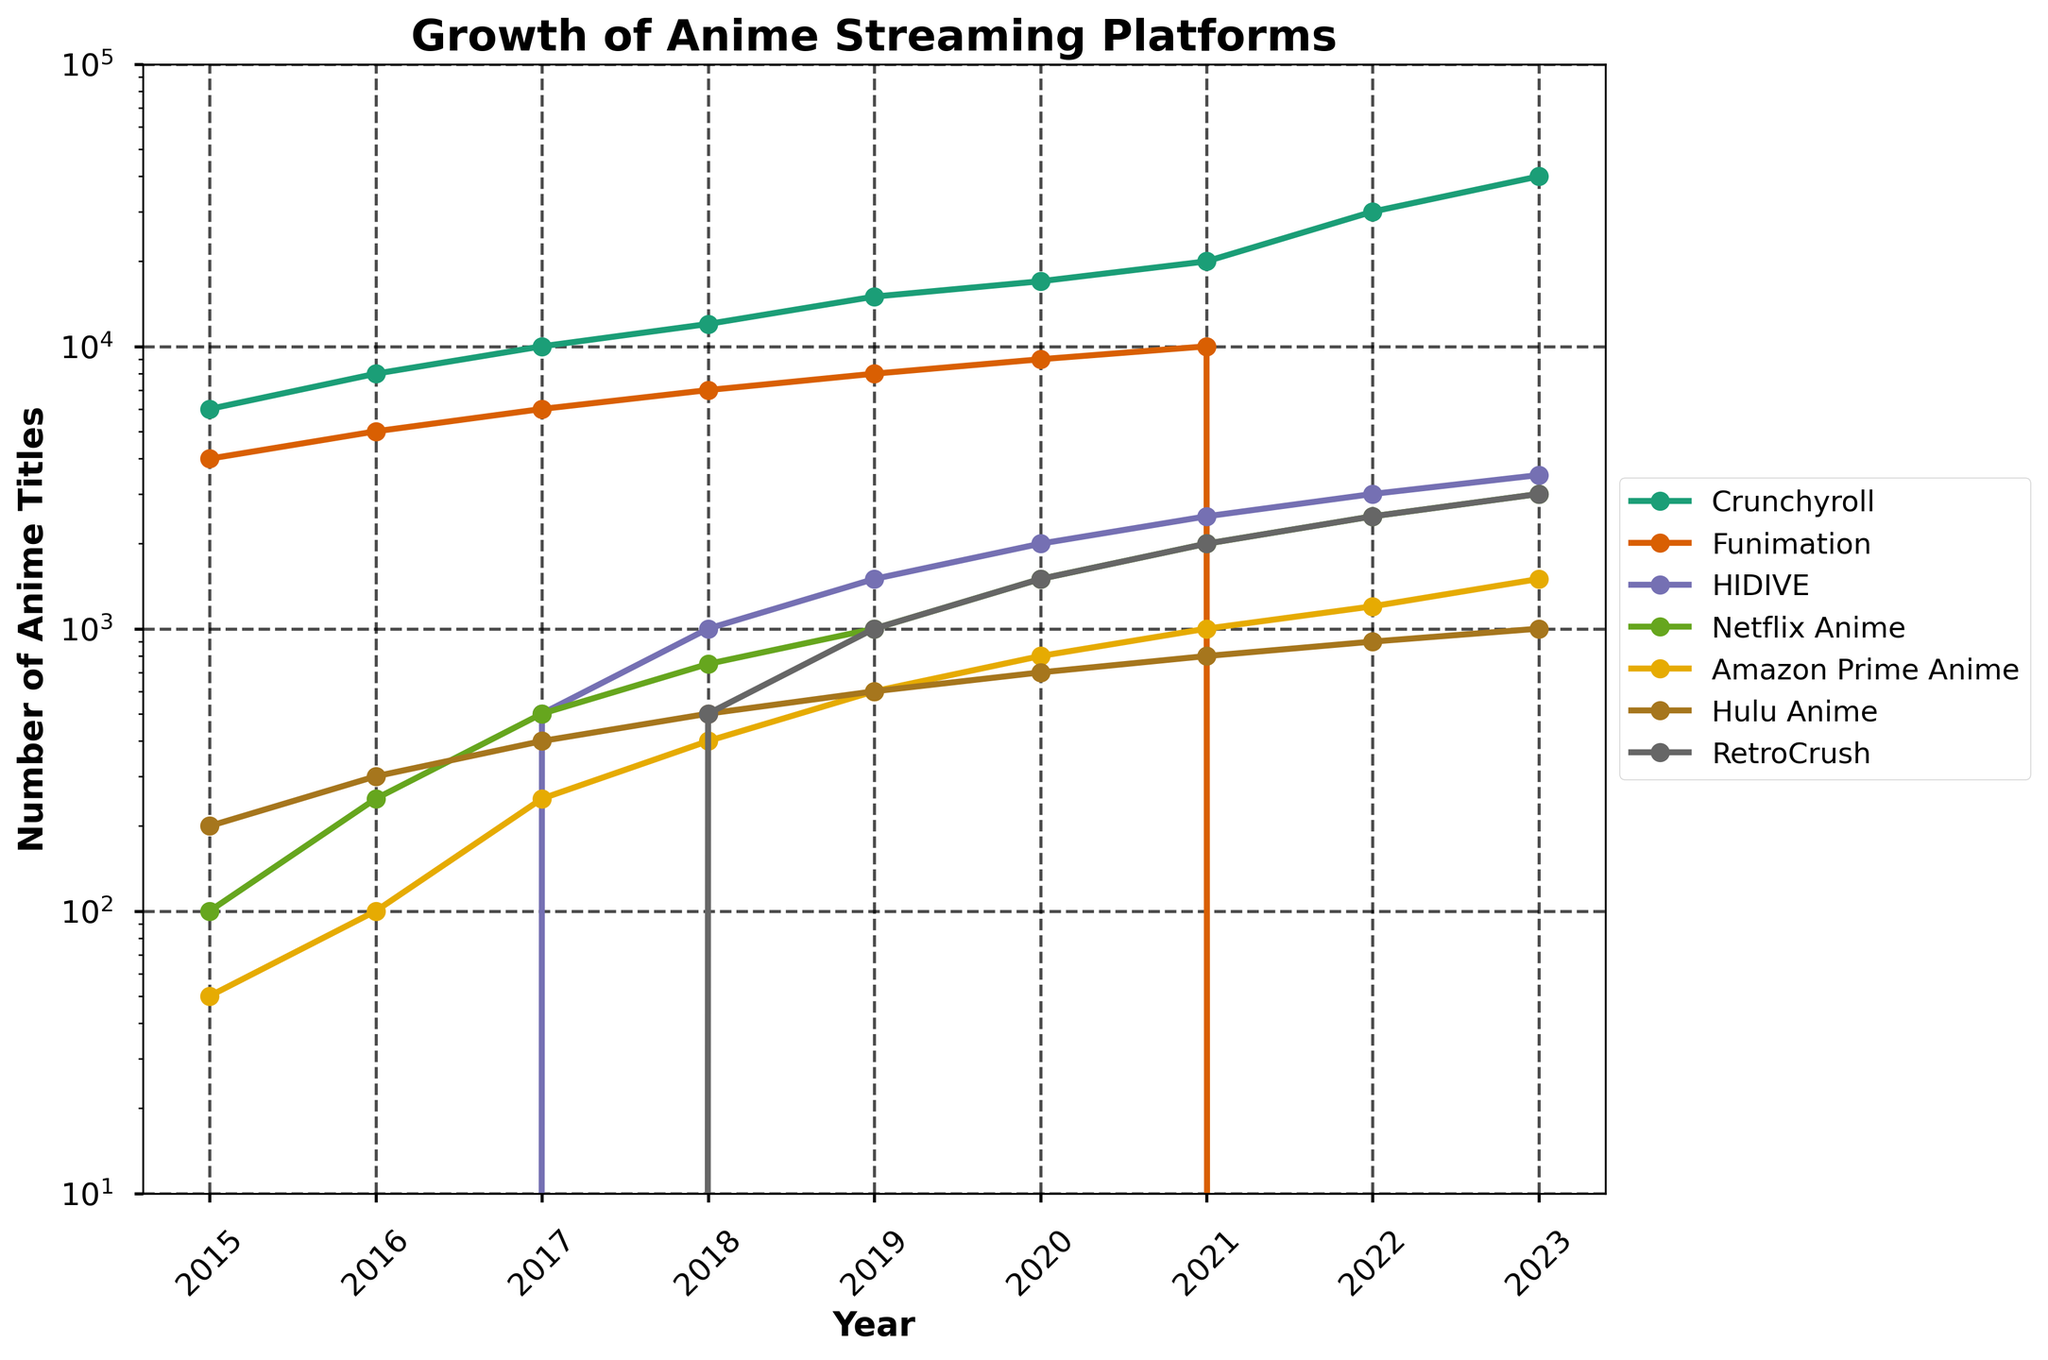Which platform had the most rapid initial growth from 2015 to 2016? To determine the initial growth, we need to compare the increase in the number of titles for each platform between 2015 and 2016. Crunchyroll grew from 6000 in 2015 to 8000 in 2016 (2000 titles), Funimation grew from 4000 to 5000 (1000 titles), HIDIVE and RetroCrush had no titles, Netflix Anime grew from 100 to 250 (150 titles), Amazon Prime Anime grew from 50 to 100 (50 titles), and Hulu Anime grew from 200 to 300 (100 titles). Crunchyroll had the highest increase of 2000 titles.
Answer: Crunchyroll Which platform had a significant decline in titles in 2022? Examining the data, Crunchyroll had 30000 titles in 2022, Funimation had 0 titles indicating a significant drop, HIDIVE had 3000, Netflix Anime had 2500, Amazon Prime Anime had 1200, Hulu Anime had 900, and RetroCrush had 2500. Funimation had a drop to 0 from 10000 in 2021.
Answer: Funimation Which platform had the largest catalog size in 2023? By reading the values for each platform in 2023, Crunchyroll had 40000 titles, Funimation had 0, HIDIVE had 3500, Netflix Anime had 3000, Amazon Prime Anime had 1500, Hulu Anime had 1000, and RetroCrush had 3000. Crunchyroll had the largest catalog size.
Answer: Crunchyroll How many titles did Netflix Anime add to its catalog from 2017 to 2019? Netflix Anime had 500 titles in 2017 and 1000 titles in 2019. The difference between 2019 and 2017 is 1000 - 500 = 500 titles.
Answer: 500 Compare the catalog sizes of Amazon Prime Anime and Hulu Anime in 2020. Which one was larger and by how many titles? In 2020, Amazon Prime Anime had 800 titles while Hulu Anime had 700 titles. The difference is 800 - 700 = 100 titles, making Amazon Prime Anime's catalog larger by 100 titles.
Answer: Amazon Prime Anime by 100 titles What is the overall trend in the number of titles for HIDIVE from 2017 to 2023? HIDIVE started with 500 titles in 2017 and gradually increased each year, reaching 3500 titles in 2023. The trend shows a steady growth over this period.
Answer: Steady growth Which years saw the introduction of new platforms in the figure? By examining the data, HIDIVE was introduced in 2017 and RetroCrush in 2018 as they had 0 titles in prior years.
Answer: 2017 for HIDIVE, 2018 for RetroCrush 